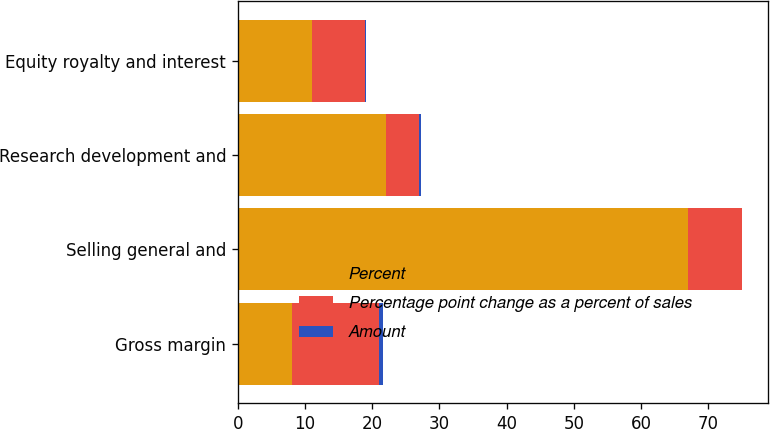Convert chart to OTSL. <chart><loc_0><loc_0><loc_500><loc_500><stacked_bar_chart><ecel><fcel>Gross margin<fcel>Selling general and<fcel>Research development and<fcel>Equity royalty and interest<nl><fcel>Percent<fcel>8<fcel>67<fcel>22<fcel>11<nl><fcel>Percentage point change as a percent of sales<fcel>13<fcel>8<fcel>5<fcel>8<nl><fcel>Amount<fcel>0.6<fcel>0.1<fcel>0.2<fcel>0.1<nl></chart> 